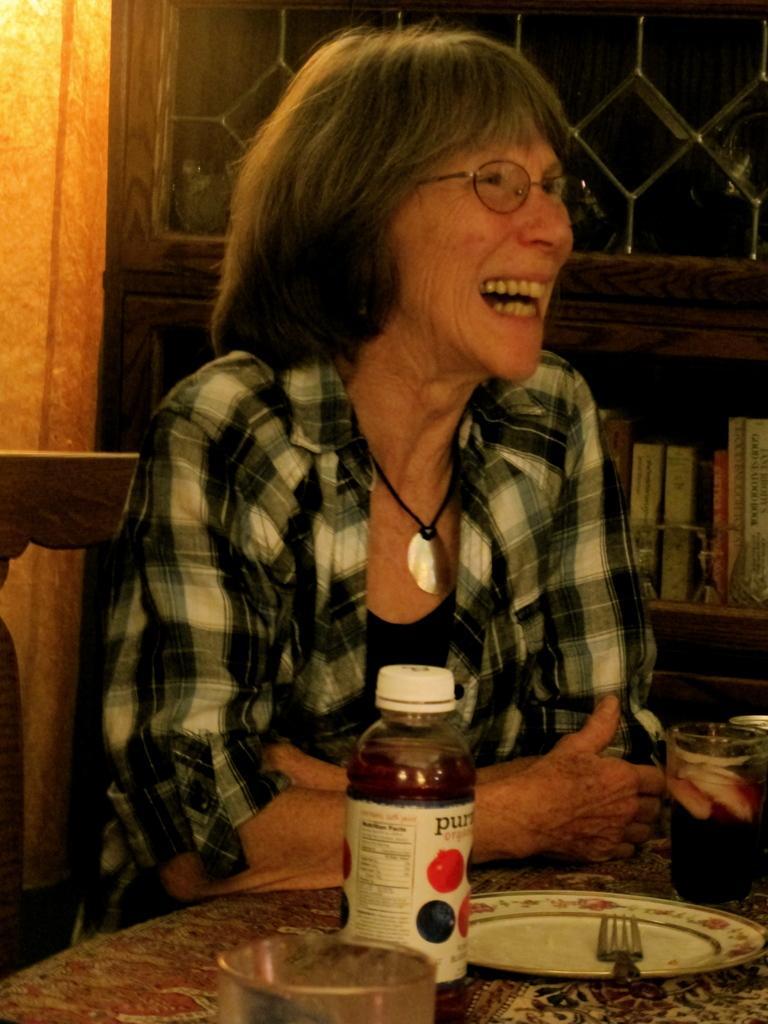In one or two sentences, can you explain what this image depicts? In this image old woman is laughing sitting on a chair leaning on the table with an empty plate and a bottle which is kept in front of her on the table. In the background there is one window and a shelf attached to it which is filled with the books. 